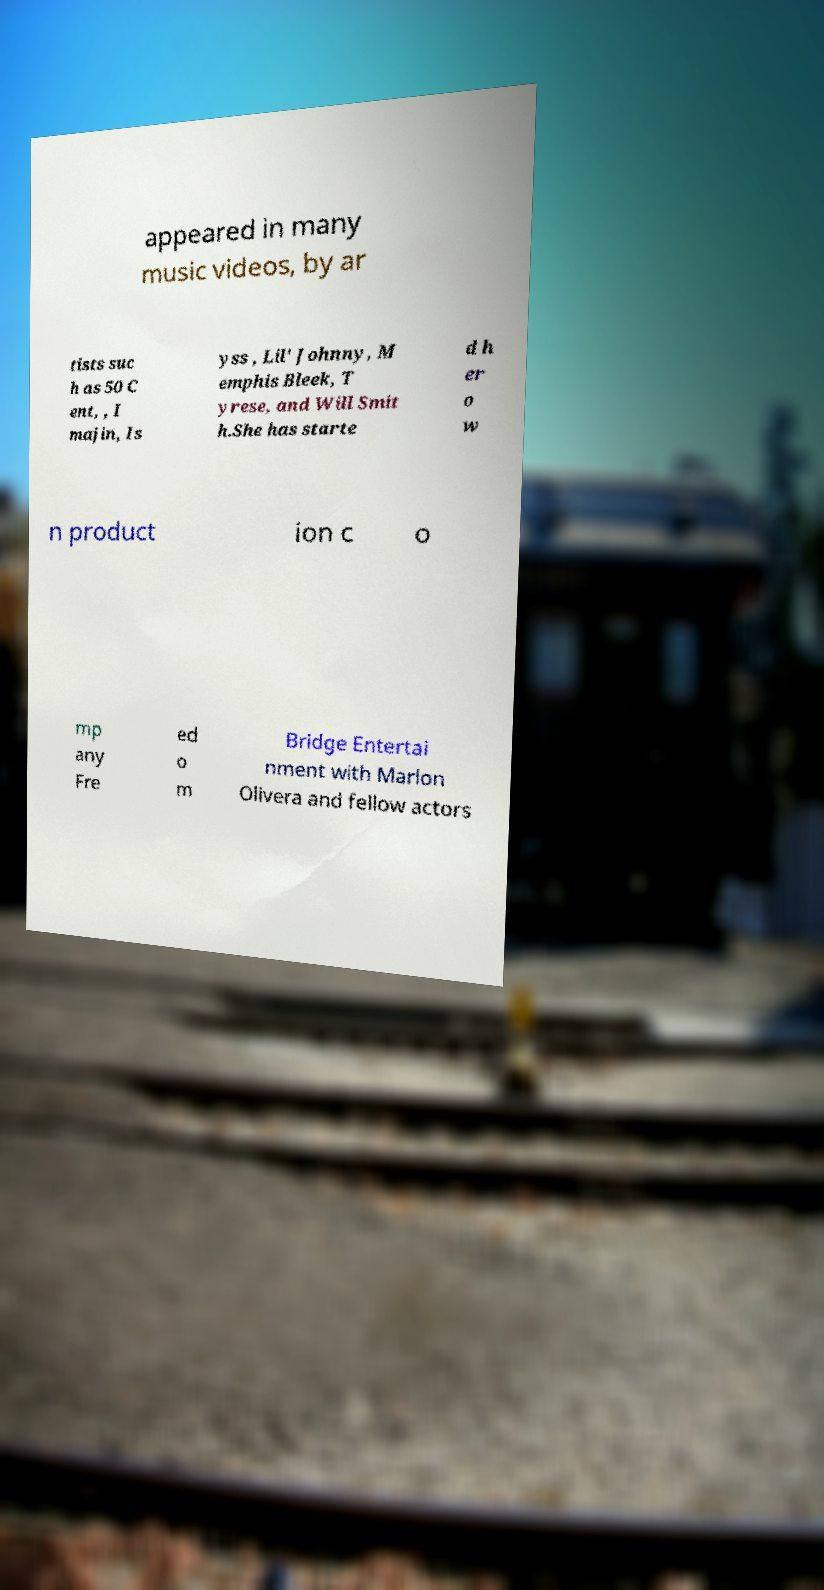Please identify and transcribe the text found in this image. appeared in many music videos, by ar tists suc h as 50 C ent, , I majin, Is yss , Lil' Johnny, M emphis Bleek, T yrese, and Will Smit h.She has starte d h er o w n product ion c o mp any Fre ed o m Bridge Entertai nment with Marlon Olivera and fellow actors 